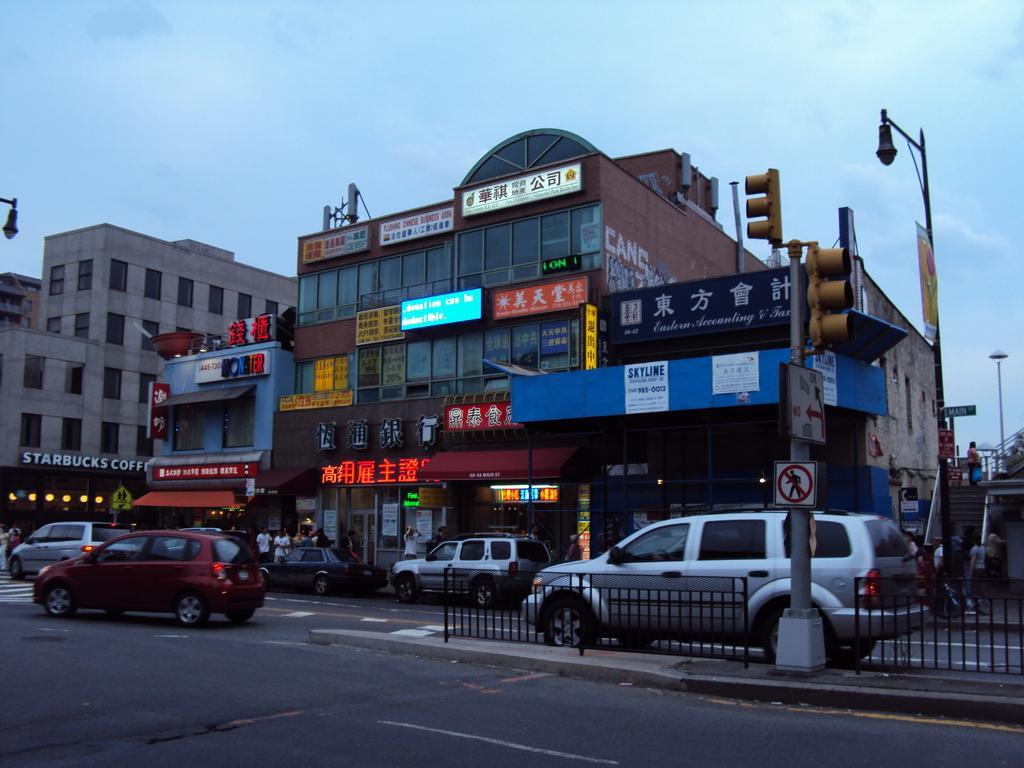What is the condition of the sky in the image? The sky is cloudy in the image. What type of structures can be seen in the image? There are buildings, hoardings, light poles, signboards, and a traffic signal in the image. What is the purpose of the fence in the image? The fence in the image serves as a barrier or boundary. What types of transportation are visible in the image? There are vehicles in the image. Are there any people present in the image? Yes, there are people in the image. What type of health advice can be seen on the street sign in the image? There is no health advice or street sign present in the image. Can you tell me how many sails are visible on the boats in the image? There are no boats or sails present in the image. 